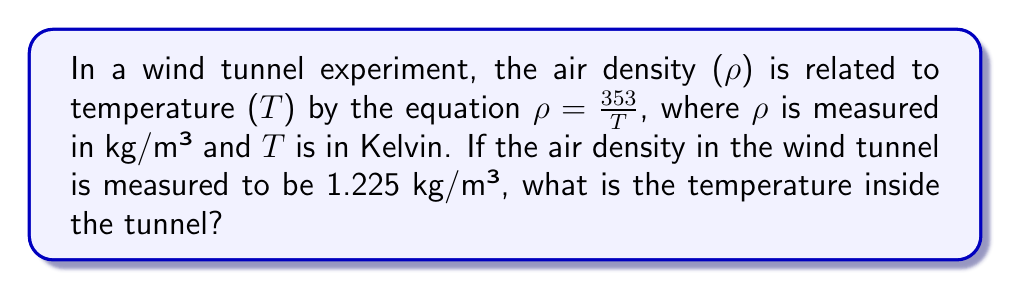Could you help me with this problem? Let's solve this step-by-step:

1) We are given the equation: $\rho = \frac{353}{T}$

2) We know that $\rho = 1.225$ kg/m³

3) Let's substitute this value into the equation:

   $1.225 = \frac{353}{T}$

4) To solve for $T$, we need to multiply both sides by $T$:

   $1.225T = 353$

5) Now, divide both sides by 1.225:

   $T = \frac{353}{1.225}$

6) Use a calculator to perform this division:

   $T \approx 288.16$ K

Therefore, the temperature inside the wind tunnel is approximately 288.16 Kelvin.
Answer: $288.16$ K 